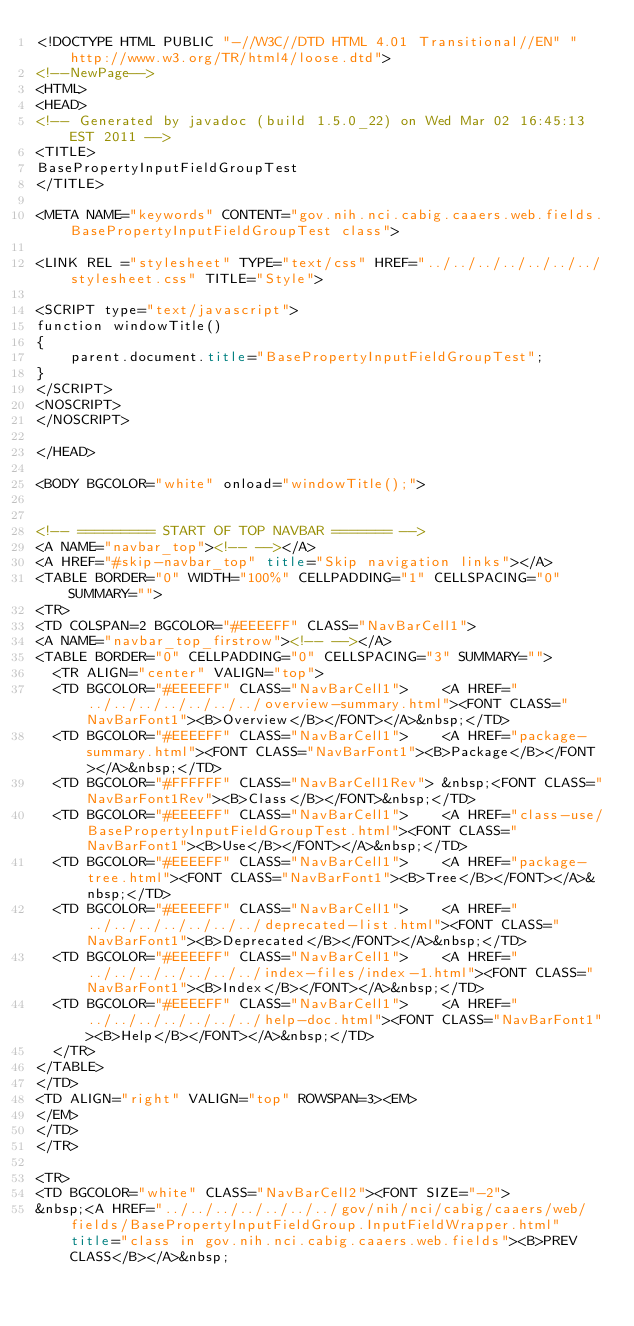<code> <loc_0><loc_0><loc_500><loc_500><_HTML_><!DOCTYPE HTML PUBLIC "-//W3C//DTD HTML 4.01 Transitional//EN" "http://www.w3.org/TR/html4/loose.dtd">
<!--NewPage-->
<HTML>
<HEAD>
<!-- Generated by javadoc (build 1.5.0_22) on Wed Mar 02 16:45:13 EST 2011 -->
<TITLE>
BasePropertyInputFieldGroupTest
</TITLE>

<META NAME="keywords" CONTENT="gov.nih.nci.cabig.caaers.web.fields.BasePropertyInputFieldGroupTest class">

<LINK REL ="stylesheet" TYPE="text/css" HREF="../../../../../../../stylesheet.css" TITLE="Style">

<SCRIPT type="text/javascript">
function windowTitle()
{
    parent.document.title="BasePropertyInputFieldGroupTest";
}
</SCRIPT>
<NOSCRIPT>
</NOSCRIPT>

</HEAD>

<BODY BGCOLOR="white" onload="windowTitle();">


<!-- ========= START OF TOP NAVBAR ======= -->
<A NAME="navbar_top"><!-- --></A>
<A HREF="#skip-navbar_top" title="Skip navigation links"></A>
<TABLE BORDER="0" WIDTH="100%" CELLPADDING="1" CELLSPACING="0" SUMMARY="">
<TR>
<TD COLSPAN=2 BGCOLOR="#EEEEFF" CLASS="NavBarCell1">
<A NAME="navbar_top_firstrow"><!-- --></A>
<TABLE BORDER="0" CELLPADDING="0" CELLSPACING="3" SUMMARY="">
  <TR ALIGN="center" VALIGN="top">
  <TD BGCOLOR="#EEEEFF" CLASS="NavBarCell1">    <A HREF="../../../../../../../overview-summary.html"><FONT CLASS="NavBarFont1"><B>Overview</B></FONT></A>&nbsp;</TD>
  <TD BGCOLOR="#EEEEFF" CLASS="NavBarCell1">    <A HREF="package-summary.html"><FONT CLASS="NavBarFont1"><B>Package</B></FONT></A>&nbsp;</TD>
  <TD BGCOLOR="#FFFFFF" CLASS="NavBarCell1Rev"> &nbsp;<FONT CLASS="NavBarFont1Rev"><B>Class</B></FONT>&nbsp;</TD>
  <TD BGCOLOR="#EEEEFF" CLASS="NavBarCell1">    <A HREF="class-use/BasePropertyInputFieldGroupTest.html"><FONT CLASS="NavBarFont1"><B>Use</B></FONT></A>&nbsp;</TD>
  <TD BGCOLOR="#EEEEFF" CLASS="NavBarCell1">    <A HREF="package-tree.html"><FONT CLASS="NavBarFont1"><B>Tree</B></FONT></A>&nbsp;</TD>
  <TD BGCOLOR="#EEEEFF" CLASS="NavBarCell1">    <A HREF="../../../../../../../deprecated-list.html"><FONT CLASS="NavBarFont1"><B>Deprecated</B></FONT></A>&nbsp;</TD>
  <TD BGCOLOR="#EEEEFF" CLASS="NavBarCell1">    <A HREF="../../../../../../../index-files/index-1.html"><FONT CLASS="NavBarFont1"><B>Index</B></FONT></A>&nbsp;</TD>
  <TD BGCOLOR="#EEEEFF" CLASS="NavBarCell1">    <A HREF="../../../../../../../help-doc.html"><FONT CLASS="NavBarFont1"><B>Help</B></FONT></A>&nbsp;</TD>
  </TR>
</TABLE>
</TD>
<TD ALIGN="right" VALIGN="top" ROWSPAN=3><EM>
</EM>
</TD>
</TR>

<TR>
<TD BGCOLOR="white" CLASS="NavBarCell2"><FONT SIZE="-2">
&nbsp;<A HREF="../../../../../../../gov/nih/nci/cabig/caaers/web/fields/BasePropertyInputFieldGroup.InputFieldWrapper.html" title="class in gov.nih.nci.cabig.caaers.web.fields"><B>PREV CLASS</B></A>&nbsp;</code> 